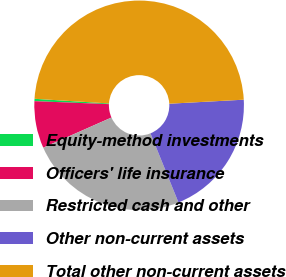Convert chart to OTSL. <chart><loc_0><loc_0><loc_500><loc_500><pie_chart><fcel>Equity-method investments<fcel>Officers' life insurance<fcel>Restricted cash and other<fcel>Other non-current assets<fcel>Total other non-current assets<nl><fcel>0.36%<fcel>7.25%<fcel>24.51%<fcel>19.73%<fcel>48.14%<nl></chart> 